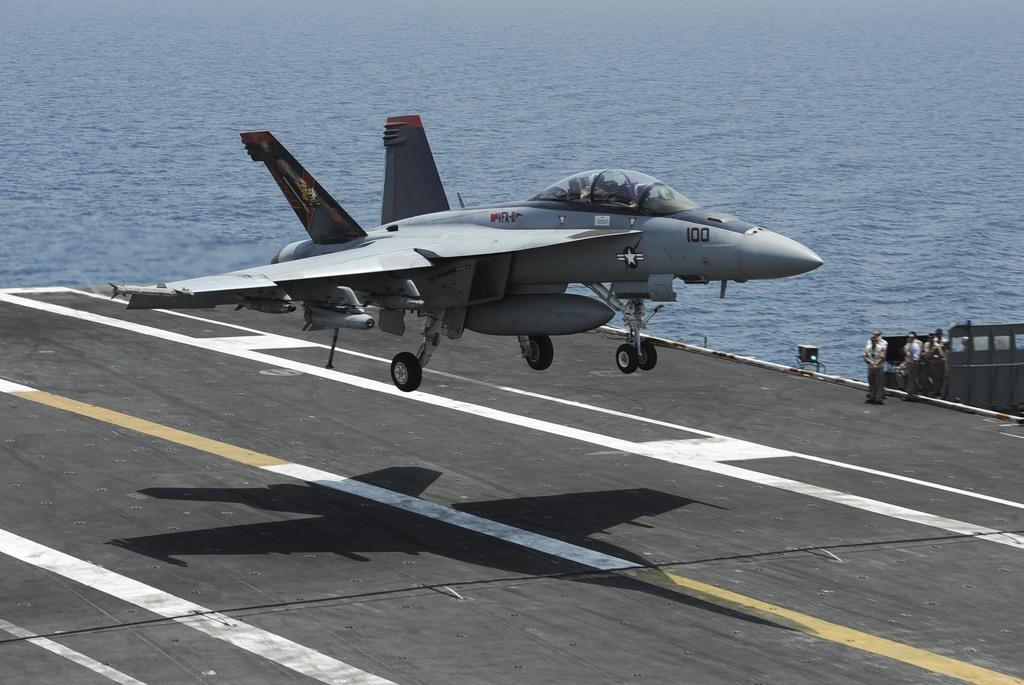How would you summarize this image in a sentence or two? In this picture there is an air craft in the center of the image and there are people those who are standing on the right side of the image, there is water in the background area of the image. 